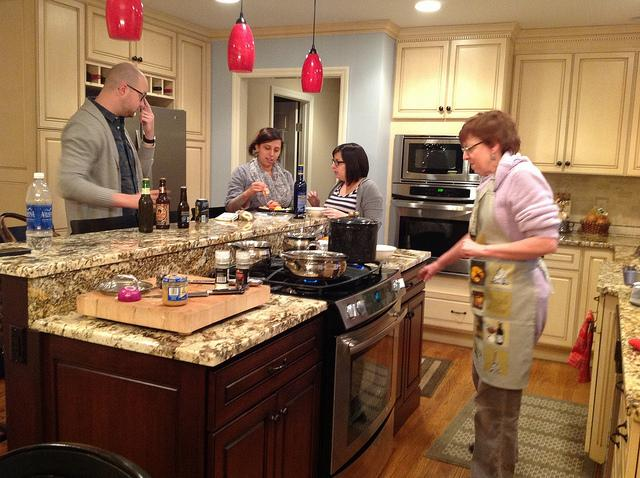What type of energy is being used by the stove?

Choices:
A) convection
B) microwave
C) gas
D) electric gas 